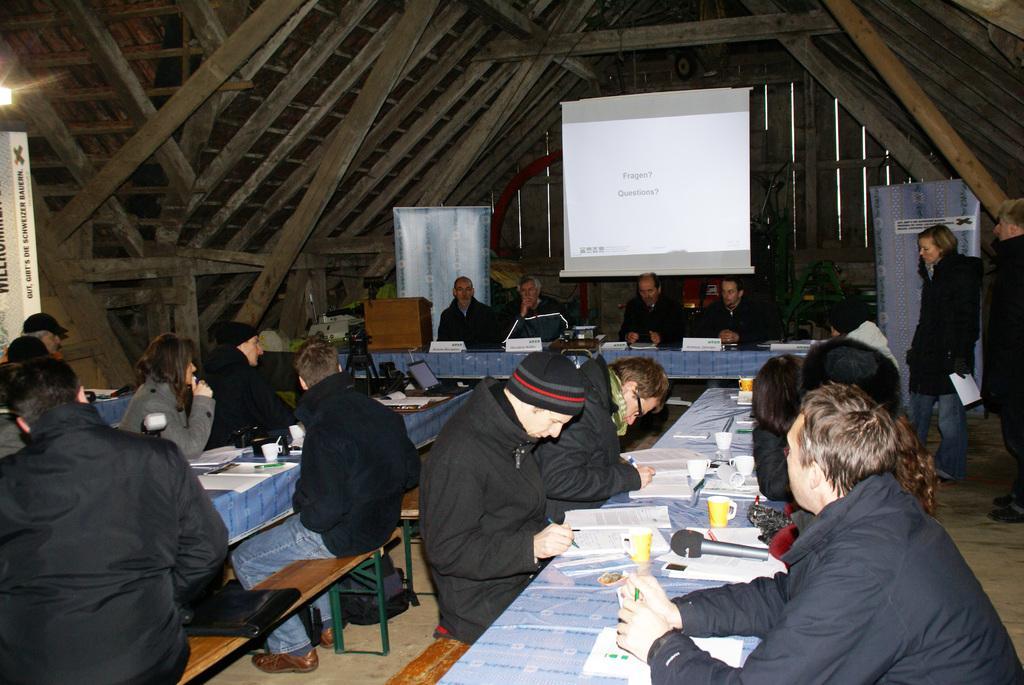Can you describe this image briefly? In the image there are few people sitting. In front of them there are tables with books, cups, laptops and some other items. In the background there is a screen hanging and also there is a podium. Behind the podium there is a poster. On the right side of the image there are two people standing and also there is a poser. At the top of the image there are wooden poles. Behind the screen there is a machine. And on the left side of the image there is a poster. 